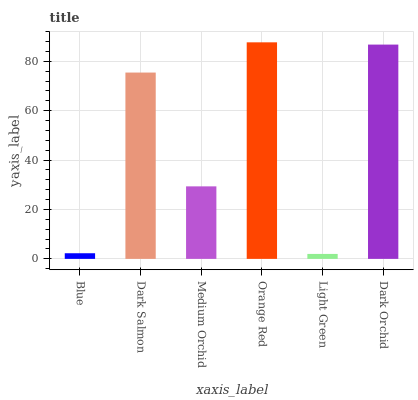Is Light Green the minimum?
Answer yes or no. Yes. Is Orange Red the maximum?
Answer yes or no. Yes. Is Dark Salmon the minimum?
Answer yes or no. No. Is Dark Salmon the maximum?
Answer yes or no. No. Is Dark Salmon greater than Blue?
Answer yes or no. Yes. Is Blue less than Dark Salmon?
Answer yes or no. Yes. Is Blue greater than Dark Salmon?
Answer yes or no. No. Is Dark Salmon less than Blue?
Answer yes or no. No. Is Dark Salmon the high median?
Answer yes or no. Yes. Is Medium Orchid the low median?
Answer yes or no. Yes. Is Blue the high median?
Answer yes or no. No. Is Orange Red the low median?
Answer yes or no. No. 